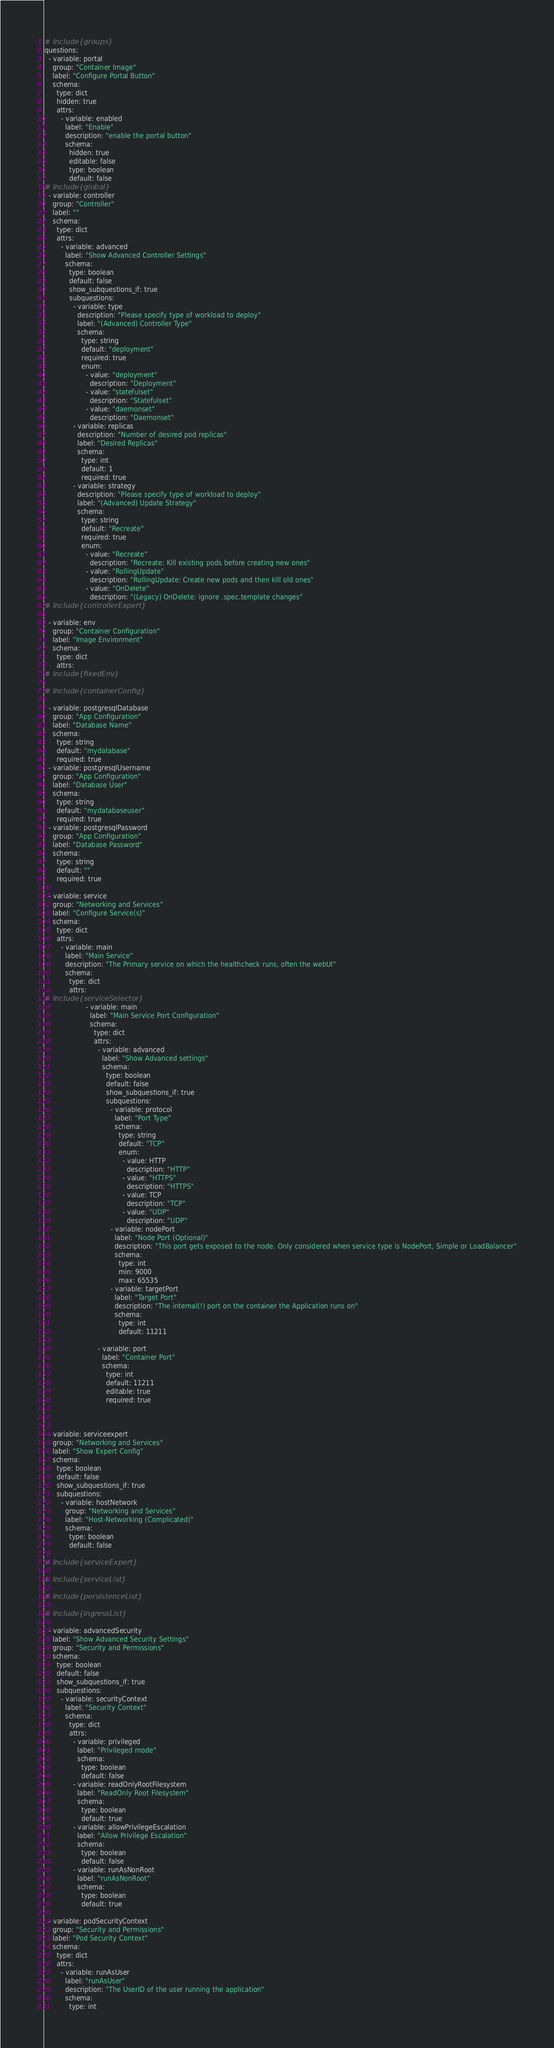<code> <loc_0><loc_0><loc_500><loc_500><_YAML_># Include{groups}
questions:
  - variable: portal
    group: "Container Image"
    label: "Configure Portal Button"
    schema:
      type: dict
      hidden: true
      attrs:
        - variable: enabled
          label: "Enable"
          description: "enable the portal button"
          schema:
            hidden: true
            editable: false
            type: boolean
            default: false
# Include{global}
  - variable: controller
    group: "Controller"
    label: ""
    schema:
      type: dict
      attrs:
        - variable: advanced
          label: "Show Advanced Controller Settings"
          schema:
            type: boolean
            default: false
            show_subquestions_if: true
            subquestions:
              - variable: type
                description: "Please specify type of workload to deploy"
                label: "(Advanced) Controller Type"
                schema:
                  type: string
                  default: "deployment"
                  required: true
                  enum:
                    - value: "deployment"
                      description: "Deployment"
                    - value: "statefulset"
                      description: "Statefulset"
                    - value: "daemonset"
                      description: "Daemonset"
              - variable: replicas
                description: "Number of desired pod replicas"
                label: "Desired Replicas"
                schema:
                  type: int
                  default: 1
                  required: true
              - variable: strategy
                description: "Please specify type of workload to deploy"
                label: "(Advanced) Update Strategy"
                schema:
                  type: string
                  default: "Recreate"
                  required: true
                  enum:
                    - value: "Recreate"
                      description: "Recreate: Kill existing pods before creating new ones"
                    - value: "RollingUpdate"
                      description: "RollingUpdate: Create new pods and then kill old ones"
                    - value: "OnDelete"
                      description: "(Legacy) OnDelete: ignore .spec.template changes"
# Include{controllerExpert}

  - variable: env
    group: "Container Configuration"
    label: "Image Environment"
    schema:
      type: dict
      attrs:
# Include{fixedEnv}

# Include{containerConfig}

  - variable: postgresqlDatabase
    group: "App Configuration"
    label: "Database Name"
    schema:
      type: string
      default: "mydatabase"
      required: true
  - variable: postgresqlUsername
    group: "App Configuration"
    label: "Database User"
    schema:
      type: string
      default: "mydatabaseuser"
      required: true
  - variable: postgresqlPassword
    group: "App Configuration"
    label: "Database Password"
    schema:
      type: string
      default: ""
      required: true

  - variable: service
    group: "Networking and Services"
    label: "Configure Service(s)"
    schema:
      type: dict
      attrs:
        - variable: main
          label: "Main Service"
          description: "The Primary service on which the healthcheck runs, often the webUI"
          schema:
            type: dict
            attrs:
# Include{serviceSelector}
                    - variable: main
                      label: "Main Service Port Configuration"
                      schema:
                        type: dict
                        attrs:
                          - variable: advanced
                            label: "Show Advanced settings"
                            schema:
                              type: boolean
                              default: false
                              show_subquestions_if: true
                              subquestions:
                                - variable: protocol
                                  label: "Port Type"
                                  schema:
                                    type: string
                                    default: "TCP"
                                    enum:
                                      - value: HTTP
                                        description: "HTTP"
                                      - value: "HTTPS"
                                        description: "HTTPS"
                                      - value: TCP
                                        description: "TCP"
                                      - value: "UDP"
                                        description: "UDP"
                                - variable: nodePort
                                  label: "Node Port (Optional)"
                                  description: "This port gets exposed to the node. Only considered when service type is NodePort, Simple or LoadBalancer"
                                  schema:
                                    type: int
                                    min: 9000
                                    max: 65535
                                - variable: targetPort
                                  label: "Target Port"
                                  description: "The internal(!) port on the container the Application runs on"
                                  schema:
                                    type: int
                                    default: 11211

                          - variable: port
                            label: "Container Port"
                            schema:
                              type: int
                              default: 11211
                              editable: true
                              required: true



  - variable: serviceexpert
    group: "Networking and Services"
    label: "Show Expert Config"
    schema:
      type: boolean
      default: false
      show_subquestions_if: true
      subquestions:
        - variable: hostNetwork
          group: "Networking and Services"
          label: "Host-Networking (Complicated)"
          schema:
            type: boolean
            default: false

# Include{serviceExpert}

# Include{serviceList}

# Include{persistenceList}

# Include{ingressList}

  - variable: advancedSecurity
    label: "Show Advanced Security Settings"
    group: "Security and Permissions"
    schema:
      type: boolean
      default: false
      show_subquestions_if: true
      subquestions:
        - variable: securityContext
          label: "Security Context"
          schema:
            type: dict
            attrs:
              - variable: privileged
                label: "Privileged mode"
                schema:
                  type: boolean
                  default: false
              - variable: readOnlyRootFilesystem
                label: "ReadOnly Root Filesystem"
                schema:
                  type: boolean
                  default: true
              - variable: allowPrivilegeEscalation
                label: "Allow Privilege Escalation"
                schema:
                  type: boolean
                  default: false
              - variable: runAsNonRoot
                label: "runAsNonRoot"
                schema:
                  type: boolean
                  default: true

  - variable: podSecurityContext
    group: "Security and Permissions"
    label: "Pod Security Context"
    schema:
      type: dict
      attrs:
        - variable: runAsUser
          label: "runAsUser"
          description: "The UserID of the user running the application"
          schema:
            type: int</code> 